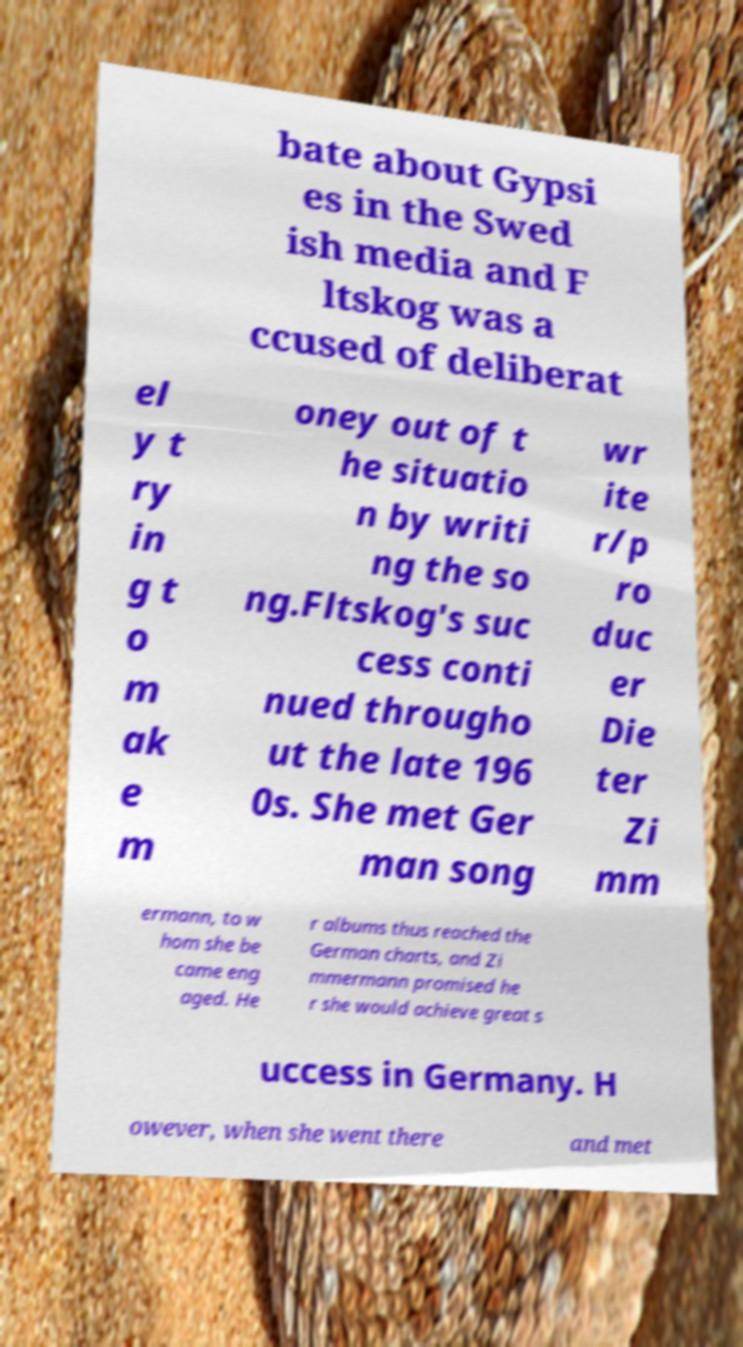Please read and relay the text visible in this image. What does it say? bate about Gypsi es in the Swed ish media and F ltskog was a ccused of deliberat el y t ry in g t o m ak e m oney out of t he situatio n by writi ng the so ng.Fltskog's suc cess conti nued througho ut the late 196 0s. She met Ger man song wr ite r/p ro duc er Die ter Zi mm ermann, to w hom she be came eng aged. He r albums thus reached the German charts, and Zi mmermann promised he r she would achieve great s uccess in Germany. H owever, when she went there and met 